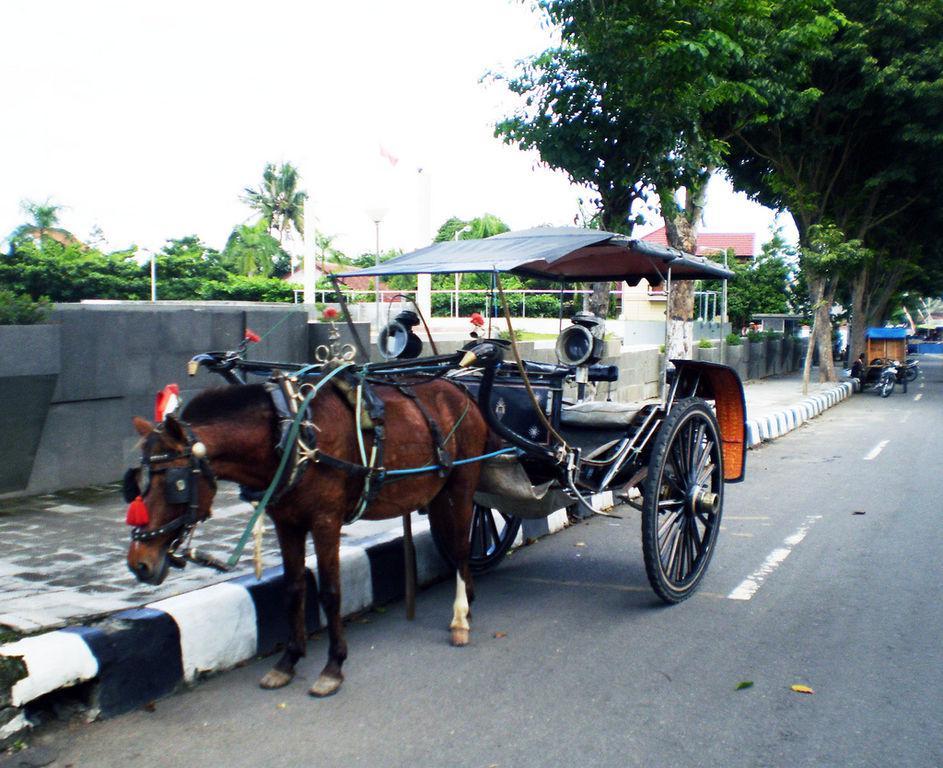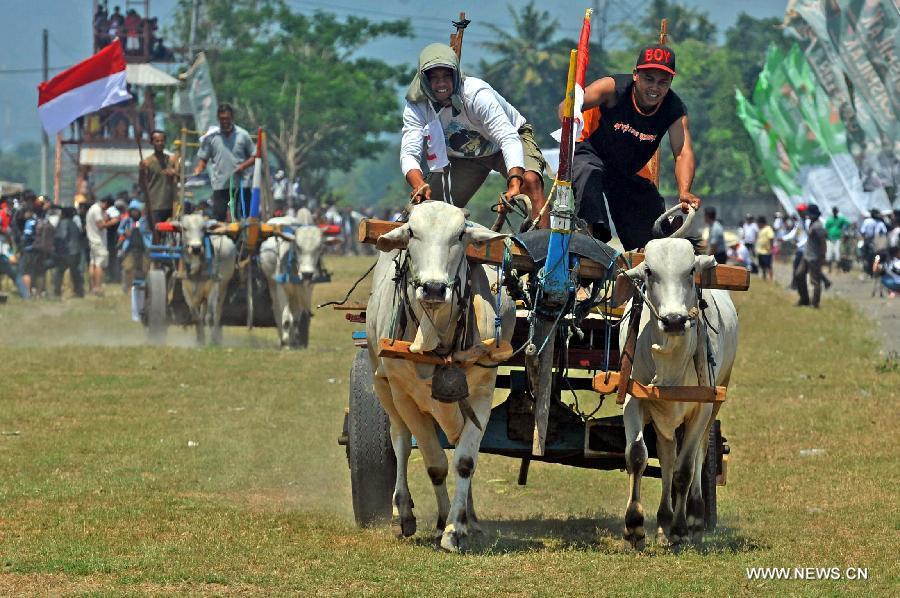The first image is the image on the left, the second image is the image on the right. Analyze the images presented: Is the assertion "An image shows a leftward-turned horse standing still with lowered head and hitched to a two-wheeled cart with a canopy top." valid? Answer yes or no. Yes. The first image is the image on the left, the second image is the image on the right. For the images shown, is this caption "The left and right image contains the same number of horses pulling a cart." true? Answer yes or no. No. 